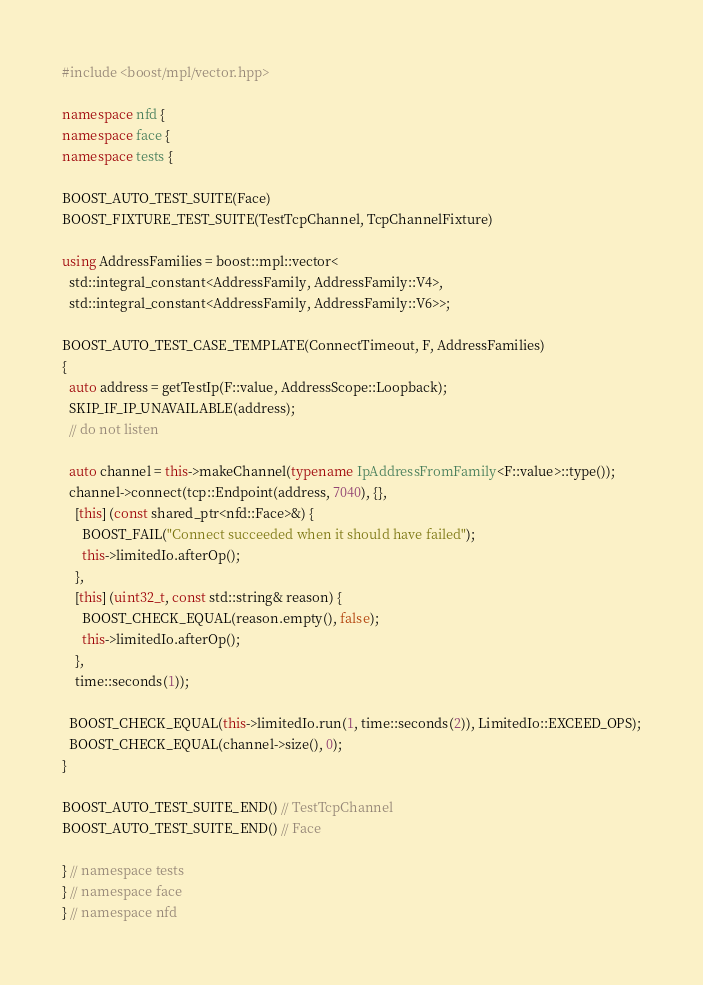<code> <loc_0><loc_0><loc_500><loc_500><_C++_>#include <boost/mpl/vector.hpp>

namespace nfd {
namespace face {
namespace tests {

BOOST_AUTO_TEST_SUITE(Face)
BOOST_FIXTURE_TEST_SUITE(TestTcpChannel, TcpChannelFixture)

using AddressFamilies = boost::mpl::vector<
  std::integral_constant<AddressFamily, AddressFamily::V4>,
  std::integral_constant<AddressFamily, AddressFamily::V6>>;

BOOST_AUTO_TEST_CASE_TEMPLATE(ConnectTimeout, F, AddressFamilies)
{
  auto address = getTestIp(F::value, AddressScope::Loopback);
  SKIP_IF_IP_UNAVAILABLE(address);
  // do not listen

  auto channel = this->makeChannel(typename IpAddressFromFamily<F::value>::type());
  channel->connect(tcp::Endpoint(address, 7040), {},
    [this] (const shared_ptr<nfd::Face>&) {
      BOOST_FAIL("Connect succeeded when it should have failed");
      this->limitedIo.afterOp();
    },
    [this] (uint32_t, const std::string& reason) {
      BOOST_CHECK_EQUAL(reason.empty(), false);
      this->limitedIo.afterOp();
    },
    time::seconds(1));

  BOOST_CHECK_EQUAL(this->limitedIo.run(1, time::seconds(2)), LimitedIo::EXCEED_OPS);
  BOOST_CHECK_EQUAL(channel->size(), 0);
}

BOOST_AUTO_TEST_SUITE_END() // TestTcpChannel
BOOST_AUTO_TEST_SUITE_END() // Face

} // namespace tests
} // namespace face
} // namespace nfd
</code> 